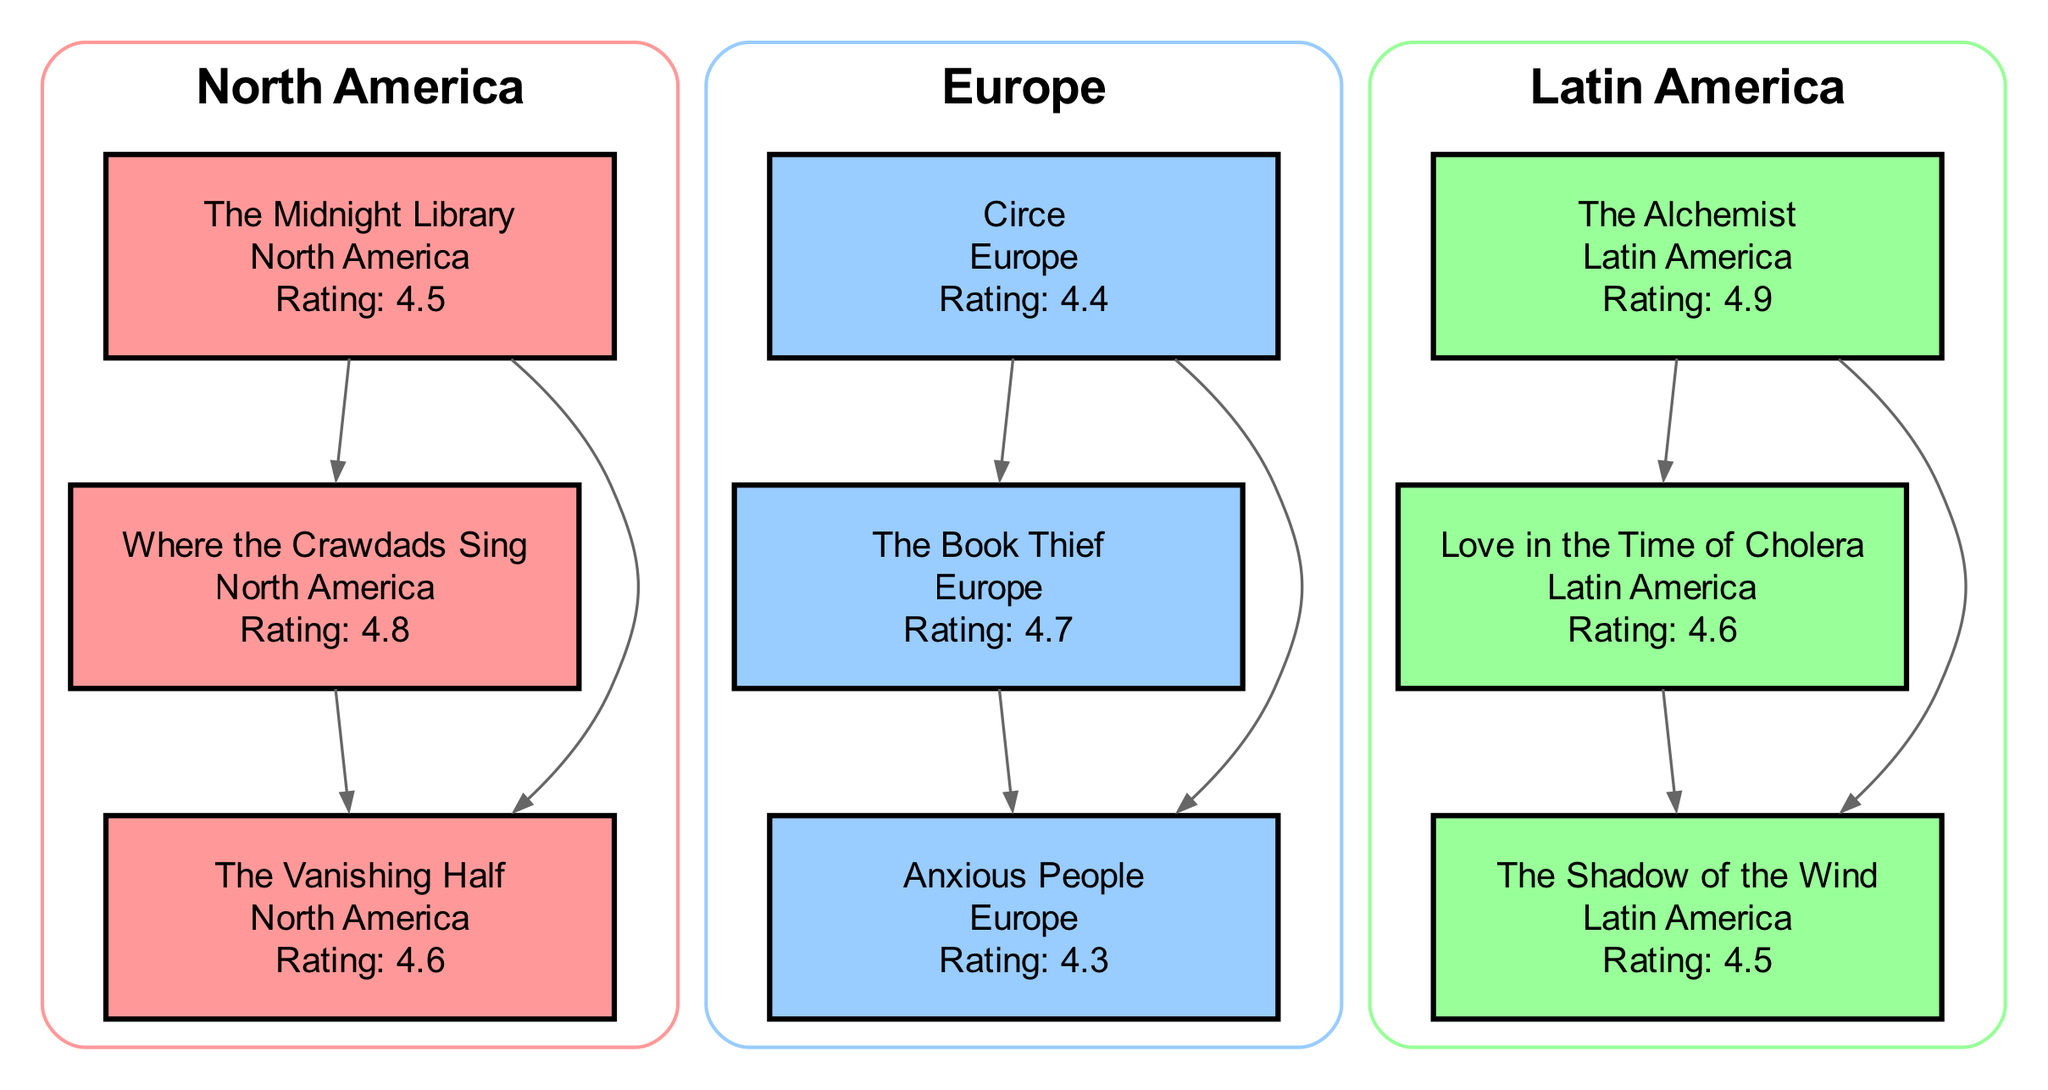What is the highest-rated book in North America? In the North America region, the ratings of the books are: "The Midnight Library" with 4.5, "Where the Crawdads Sing" with 4.8, and "The Vanishing Half" with 4.6. The highest rating among these is 4.8, which belongs to "Where the Crawdads Sing."
Answer: Where the Crawdads Sing Which book has the lowest rating in Europe? The ratings for the European region are: "Circe" with 4.4, "The Book Thief" with 4.7, and "Anxious People" with 4.3. The lowest rating is 4.3, attributed to "Anxious People."
Answer: Anxious People How many books are represented in the diagram? By counting the nodes in the diagram, there are a total of 9 books listed: "The Midnight Library," "Where the Crawdads Sing," "The Vanishing Half," "Circe," "The Book Thief," "Anxious People," "The Alchemist," "Love in the Time of Cholera," and "The Shadow of the Wind."
Answer: 9 Which region has the book "The Alchemist"? Looking at the node details, "The Alchemist" is listed under the Latin America region.
Answer: Latin America How many edges are there connecting the books in North America? The North American connections are: "The Midnight Library" to "Where the Crawdads Sing," "The Midnight Library" to "The Vanishing Half," and "Where the Crawdads Sing" to "The Vanishing Half." This gives a total of 3 edges connecting the books in that region.
Answer: 3 What is the rating of "The Shadow of the Wind"? The rating for "The Shadow of the Wind," as indicated in the diagram, is 4.5.
Answer: 4.5 Which book connects with "Love in the Time of Cholera" in Latin America? The edges indicate that "Love in the Time of Cholera" connects to "The Shadow of the Wind" in Latin America.
Answer: The Shadow of the Wind Which region has the overall highest individual book rating? In the Latin America region, "The Alchemist" has the highest rating of 4.9, which is greater than the highest ratings in North America (4.8) and Europe (4.7), indicating Latin America has the highest individual book rating overall.
Answer: Latin America How many books are rated 4.6 or higher in Europe? In Europe, the ratings are: "Circe" with 4.4, "The Book Thief" with 4.7, and "Anxious People" with 4.3. Only "The Book Thief" meets the criteria of being rated 4.6 or higher, giving a total of 1 book in this category.
Answer: 1 